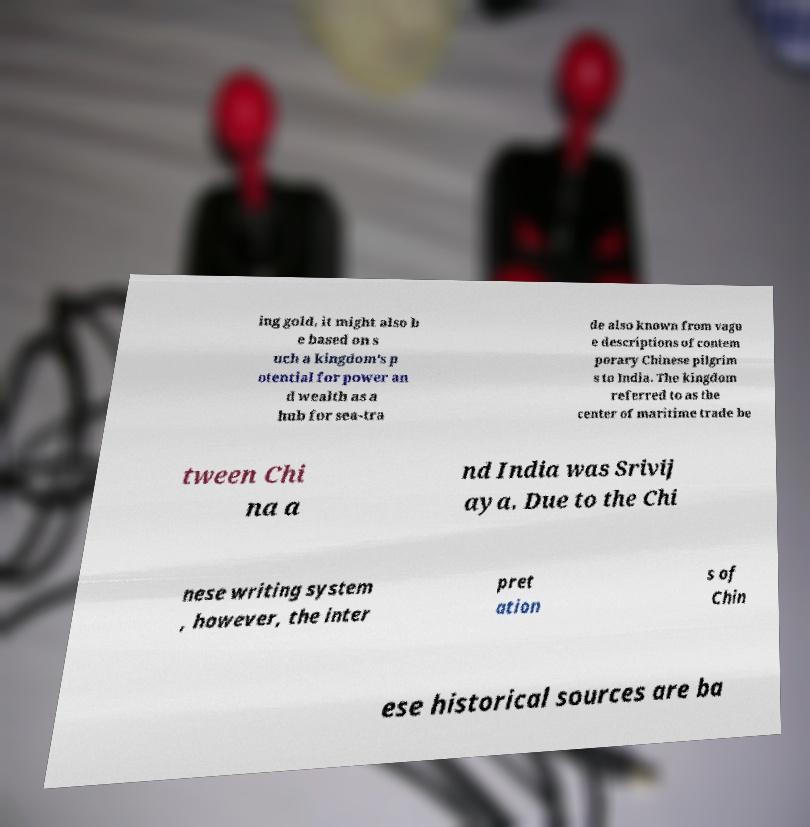What messages or text are displayed in this image? I need them in a readable, typed format. ing gold, it might also b e based on s uch a kingdom's p otential for power an d wealth as a hub for sea-tra de also known from vagu e descriptions of contem porary Chinese pilgrim s to India. The kingdom referred to as the center of maritime trade be tween Chi na a nd India was Srivij aya. Due to the Chi nese writing system , however, the inter pret ation s of Chin ese historical sources are ba 